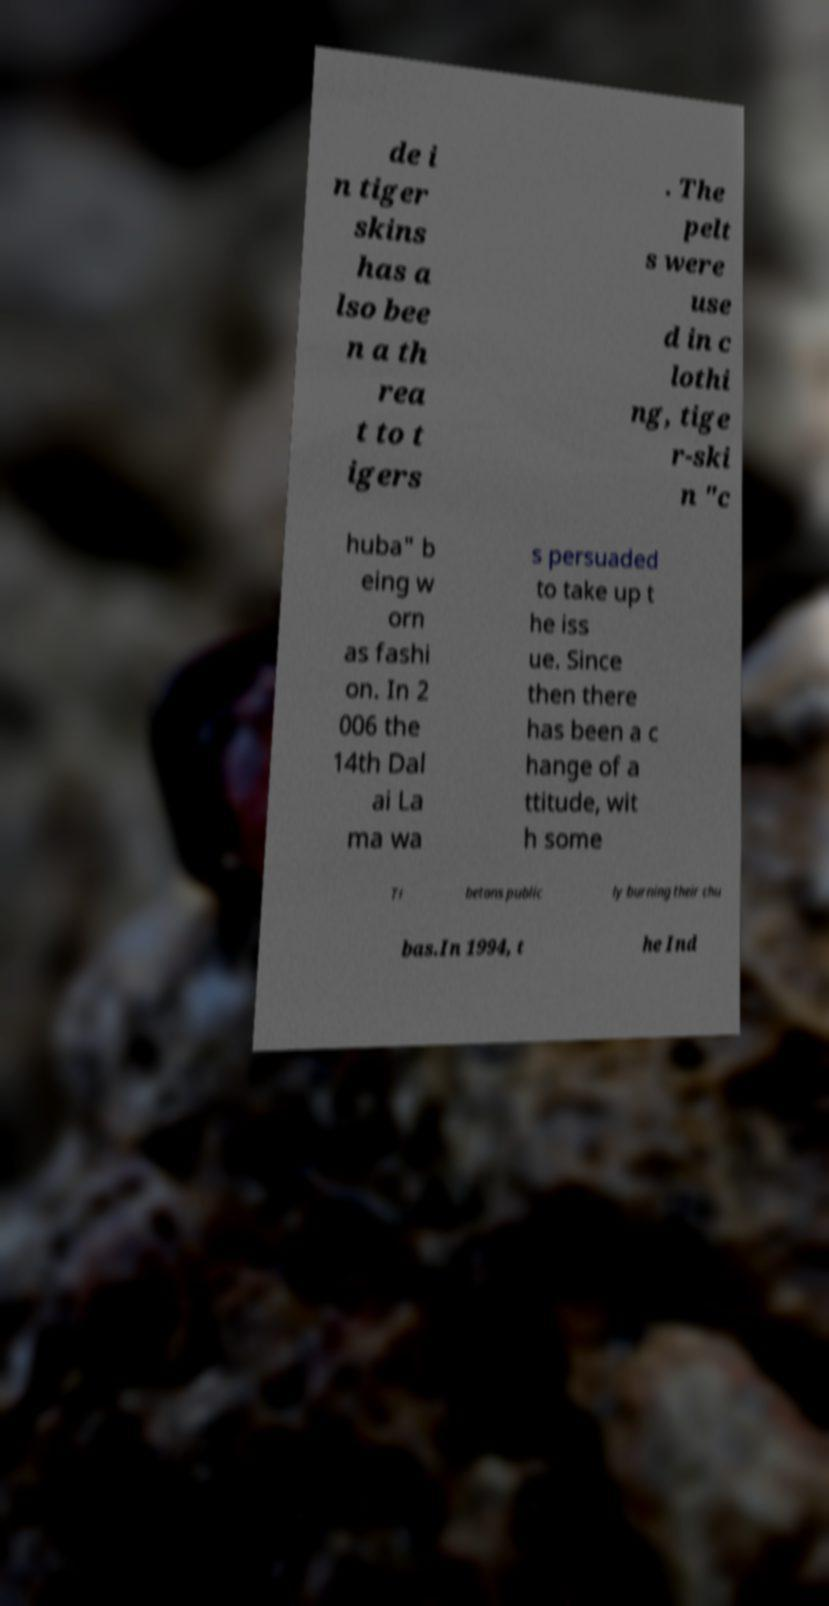Please identify and transcribe the text found in this image. de i n tiger skins has a lso bee n a th rea t to t igers . The pelt s were use d in c lothi ng, tige r-ski n "c huba" b eing w orn as fashi on. In 2 006 the 14th Dal ai La ma wa s persuaded to take up t he iss ue. Since then there has been a c hange of a ttitude, wit h some Ti betans public ly burning their chu bas.In 1994, t he Ind 